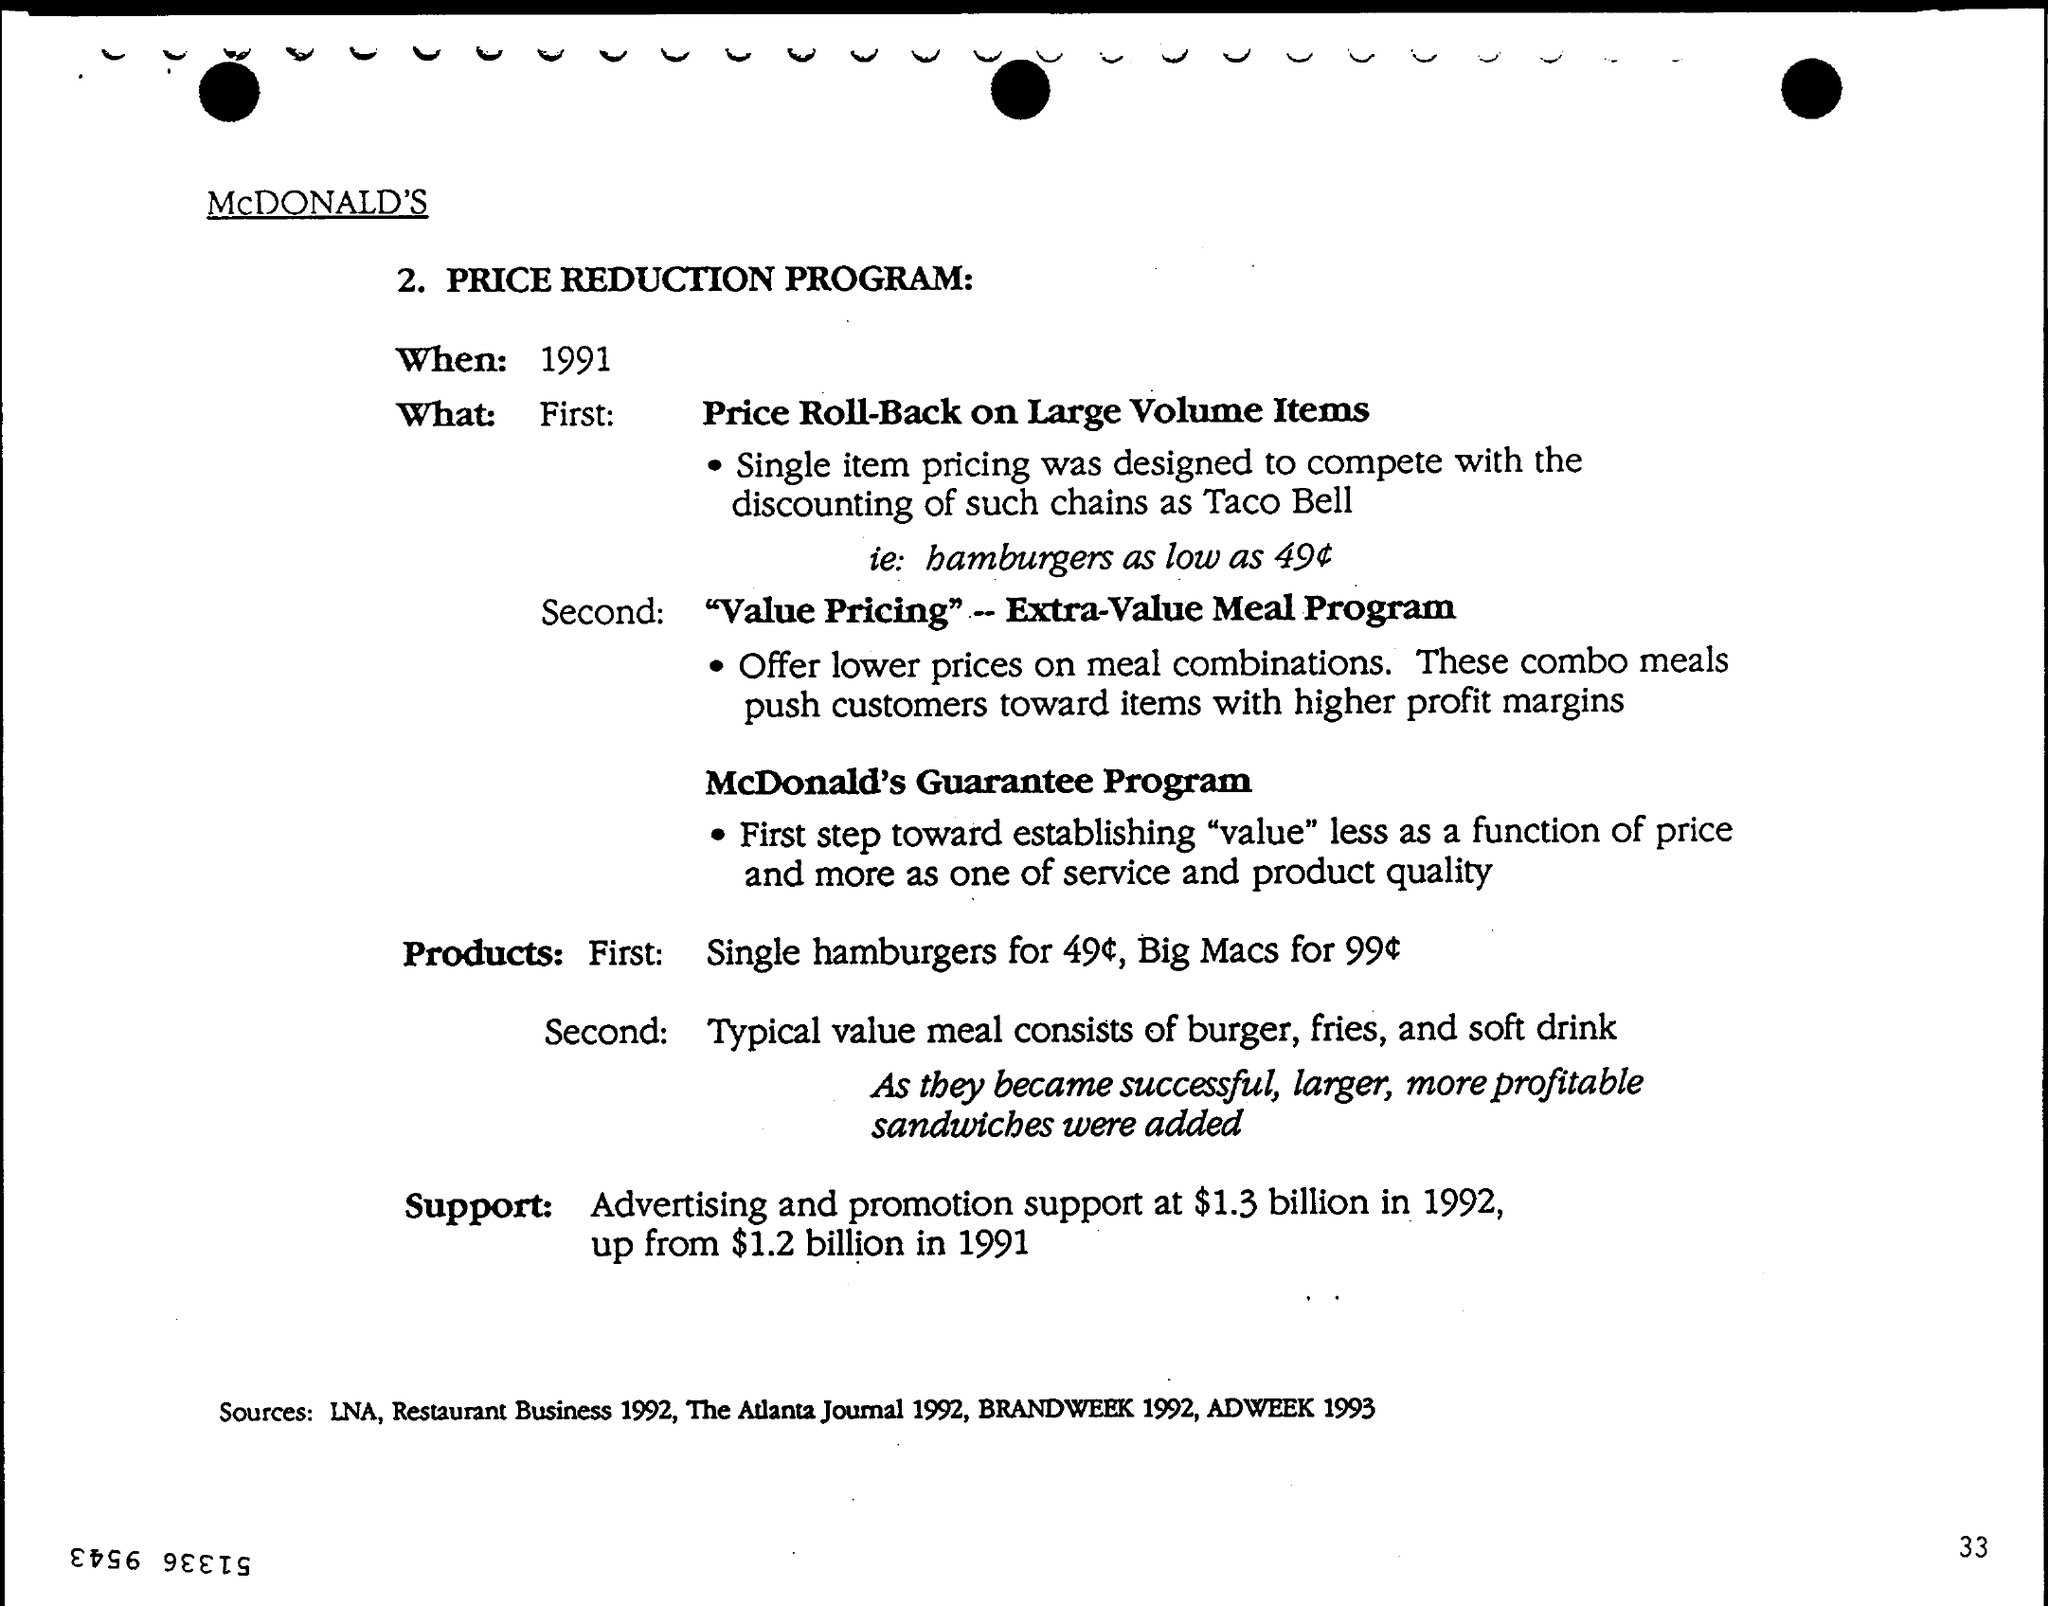When is the PRICE REDUCTION PROGRAM?
Offer a very short reply. 1991. Which brand is mentioned?
Give a very brief answer. McDONALD'S. 